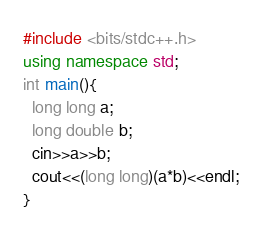Convert code to text. <code><loc_0><loc_0><loc_500><loc_500><_C++_>#include <bits/stdc++.h>
using namespace std;
int main(){
  long long a;
  long double b;
  cin>>a>>b;
  cout<<(long long)(a*b)<<endl;
}</code> 